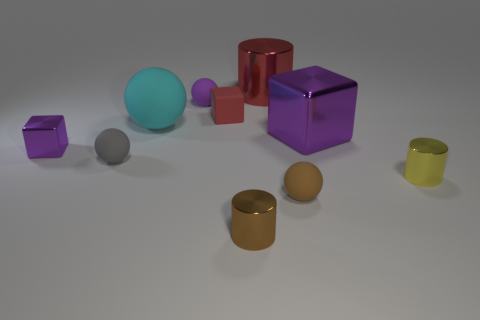What is the material of the tiny cylinder that is right of the metal cylinder that is left of the large cylinder?
Make the answer very short. Metal. There is a purple block that is on the right side of the big cyan object that is to the right of the purple block to the left of the large cube; how big is it?
Provide a succinct answer. Large. What number of small gray objects are made of the same material as the big purple block?
Offer a very short reply. 0. What is the color of the big ball on the left side of the rubber ball that is in front of the tiny gray object?
Offer a very short reply. Cyan. How many things are yellow objects or small objects that are behind the tiny gray ball?
Offer a very short reply. 4. Are there any tiny balls of the same color as the tiny matte block?
Offer a terse response. No. How many cyan objects are either matte objects or large rubber cubes?
Your answer should be compact. 1. How many other objects are the same size as the yellow cylinder?
Keep it short and to the point. 6. What number of large things are brown matte things or yellow metal cylinders?
Your response must be concise. 0. Does the red metal object have the same size as the cyan thing that is in front of the large red shiny object?
Make the answer very short. Yes. 